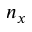<formula> <loc_0><loc_0><loc_500><loc_500>n _ { x }</formula> 